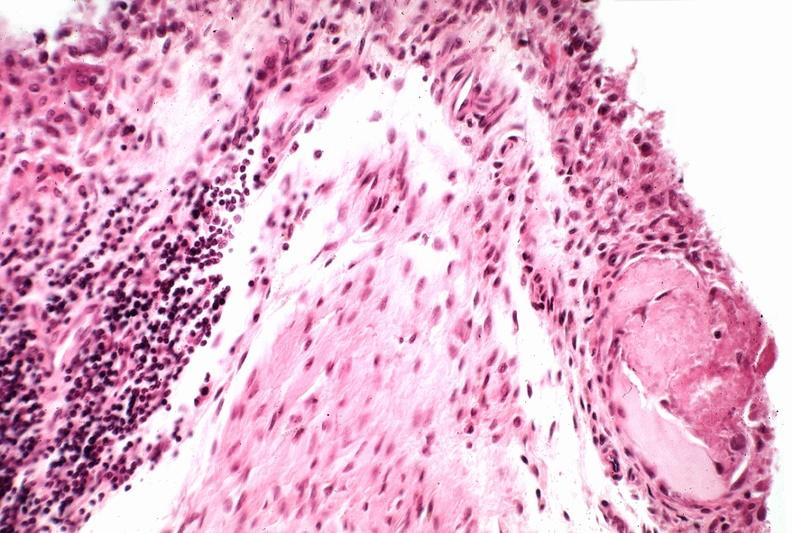what is present?
Answer the question using a single word or phrase. Joints 